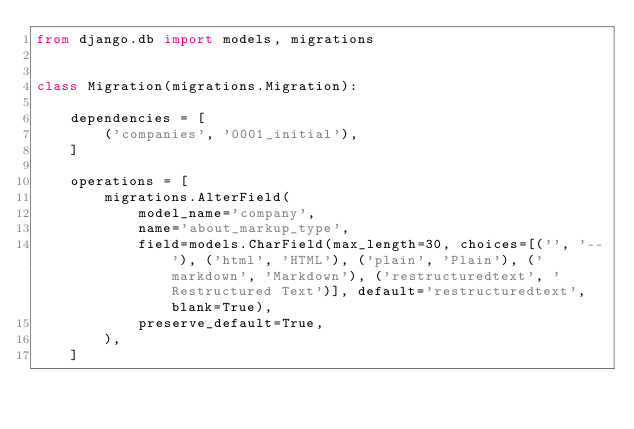Convert code to text. <code><loc_0><loc_0><loc_500><loc_500><_Python_>from django.db import models, migrations


class Migration(migrations.Migration):

    dependencies = [
        ('companies', '0001_initial'),
    ]

    operations = [
        migrations.AlterField(
            model_name='company',
            name='about_markup_type',
            field=models.CharField(max_length=30, choices=[('', '--'), ('html', 'HTML'), ('plain', 'Plain'), ('markdown', 'Markdown'), ('restructuredtext', 'Restructured Text')], default='restructuredtext', blank=True),
            preserve_default=True,
        ),
    ]
</code> 